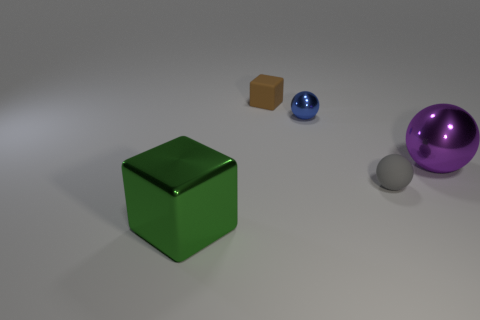Subtract all blue spheres. How many spheres are left? 2 Add 2 tiny objects. How many objects exist? 7 Subtract all blue balls. How many balls are left? 2 Add 4 blue metallic balls. How many blue metallic balls are left? 5 Add 5 small blocks. How many small blocks exist? 6 Subtract 1 purple spheres. How many objects are left? 4 Subtract all spheres. How many objects are left? 2 Subtract all gray spheres. Subtract all blue blocks. How many spheres are left? 2 Subtract all tiny brown rubber balls. Subtract all big green metallic blocks. How many objects are left? 4 